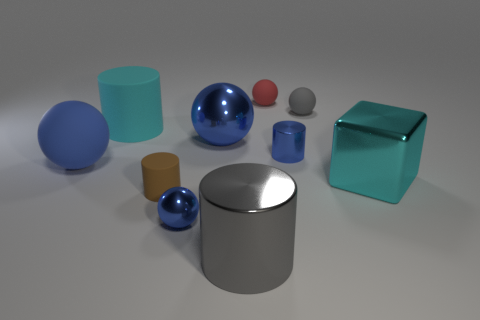There is a tiny blue metallic thing on the right side of the gray shiny thing; does it have the same shape as the cyan shiny thing?
Your answer should be compact. No. What is the material of the small gray sphere?
Your response must be concise. Rubber. There is a blue metallic thing that is the same size as the blue metallic cylinder; what shape is it?
Your response must be concise. Sphere. Are there any other large blocks of the same color as the cube?
Your response must be concise. No. There is a small metal cylinder; does it have the same color as the metallic object behind the blue metallic cylinder?
Your response must be concise. Yes. The small thing that is left of the metal ball in front of the tiny blue cylinder is what color?
Provide a short and direct response. Brown. There is a tiny blue object behind the blue metallic object in front of the small rubber cylinder; is there a cyan thing on the right side of it?
Your answer should be very brief. Yes. There is a large cube that is made of the same material as the large gray cylinder; what is its color?
Ensure brevity in your answer.  Cyan. What number of blue objects are the same material as the tiny blue cylinder?
Your answer should be very brief. 2. Does the big cube have the same material as the gray object that is to the right of the gray metal thing?
Your response must be concise. No. 